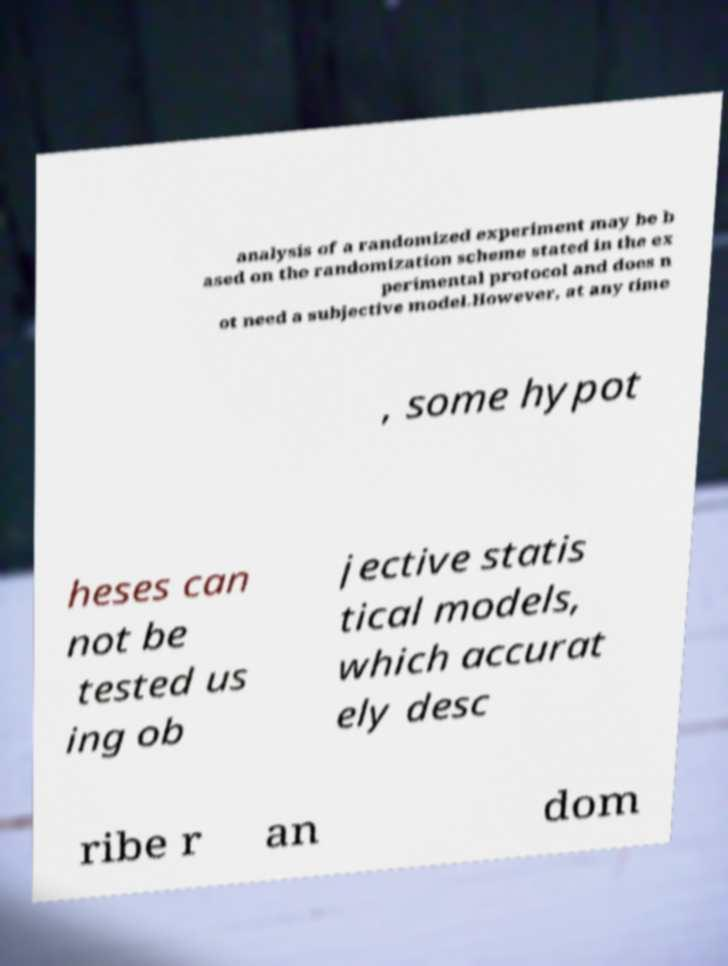Please read and relay the text visible in this image. What does it say? analysis of a randomized experiment may be b ased on the randomization scheme stated in the ex perimental protocol and does n ot need a subjective model.However, at any time , some hypot heses can not be tested us ing ob jective statis tical models, which accurat ely desc ribe r an dom 